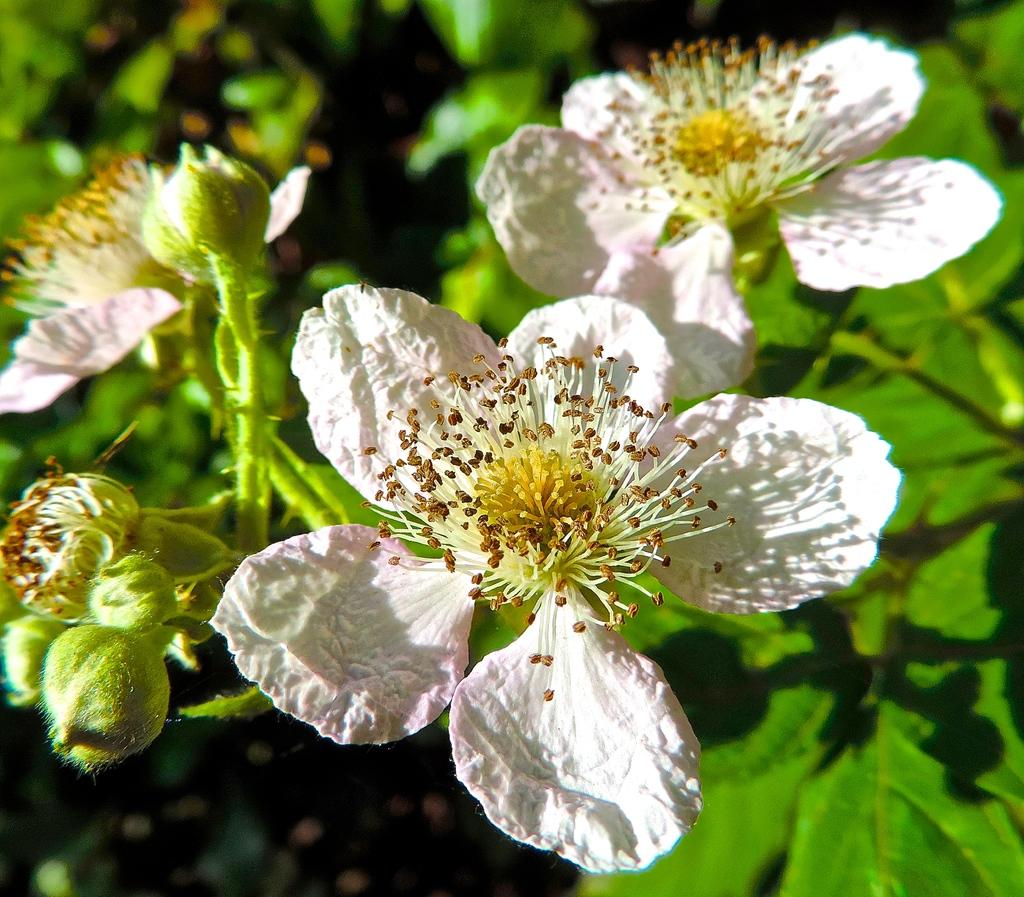What type of flowers can be seen in the image? There are white color flowers in the image. What parts of the flowers are visible in the image? Stems are visible in the image. Are there any other plant parts visible in the image besides the flowers and stems? Yes, leaves are present in the image. What type of camera is used to take the picture of the son bursting into tears? There is no camera, son, or bursting into tears present in the image. The image only contains white color flowers, stems, and leaves. 